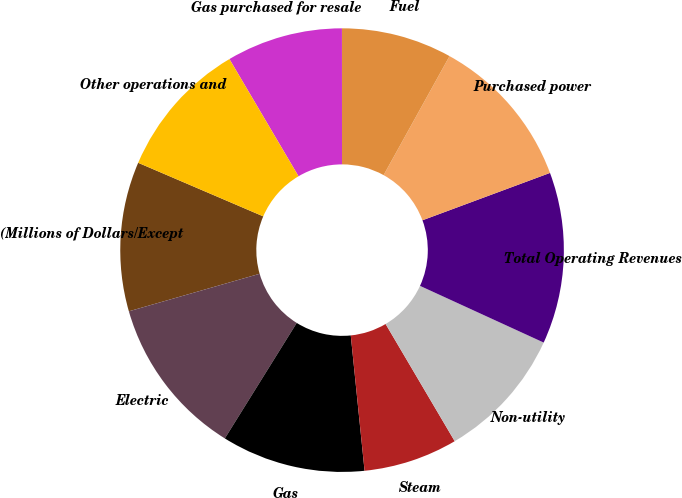Convert chart to OTSL. <chart><loc_0><loc_0><loc_500><loc_500><pie_chart><fcel>(Millions of Dollars/Except<fcel>Electric<fcel>Gas<fcel>Steam<fcel>Non-utility<fcel>Total Operating Revenues<fcel>Purchased power<fcel>Fuel<fcel>Gas purchased for resale<fcel>Other operations and<nl><fcel>10.89%<fcel>11.69%<fcel>10.48%<fcel>6.86%<fcel>9.68%<fcel>12.5%<fcel>11.29%<fcel>8.06%<fcel>8.47%<fcel>10.08%<nl></chart> 